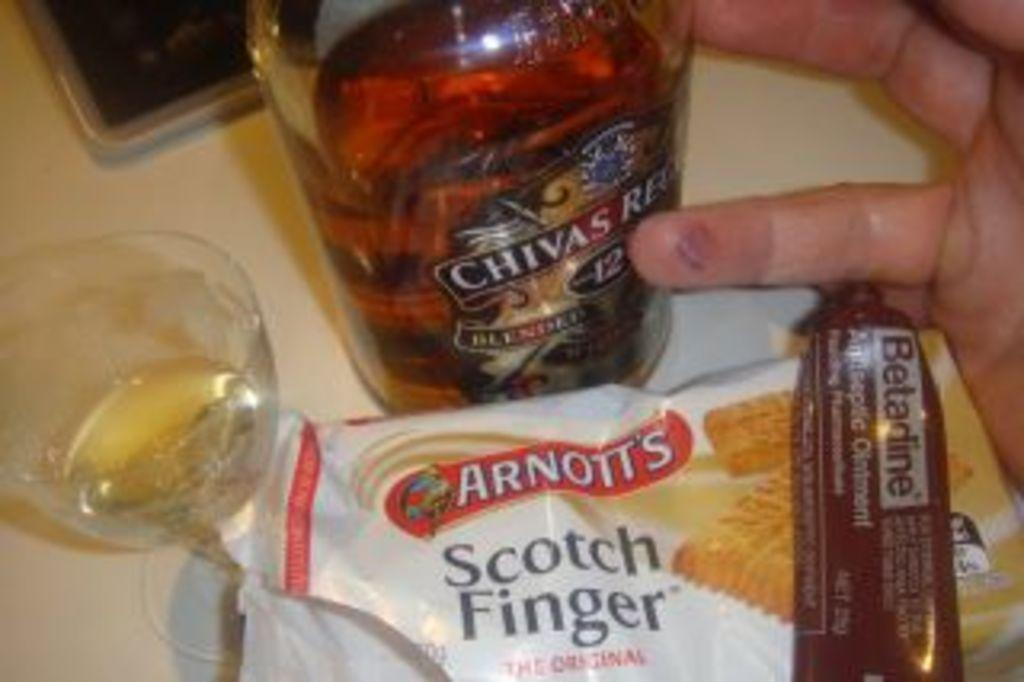Provide a one-sentence caption for the provided image. A close up of someone's hand next to an assortment of snacks, a tumbler and a bottle of Chivas Regal. 